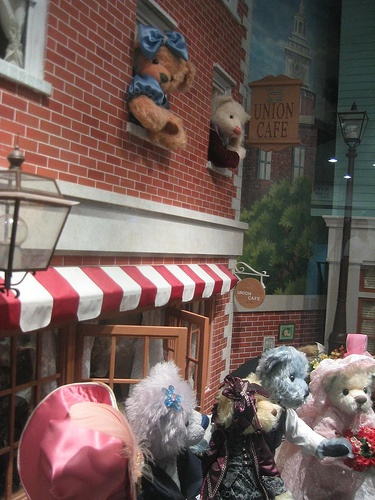Describe the objects in this image and their specific colors. I can see teddy bear in gray, maroon, pink, brown, and lightpink tones, teddy bear in gray, darkgray, and lightgray tones, teddy bear in gray, black, and darkgray tones, teddy bear in gray, black, darkgray, and lightgray tones, and teddy bear in gray, black, and brown tones in this image. 